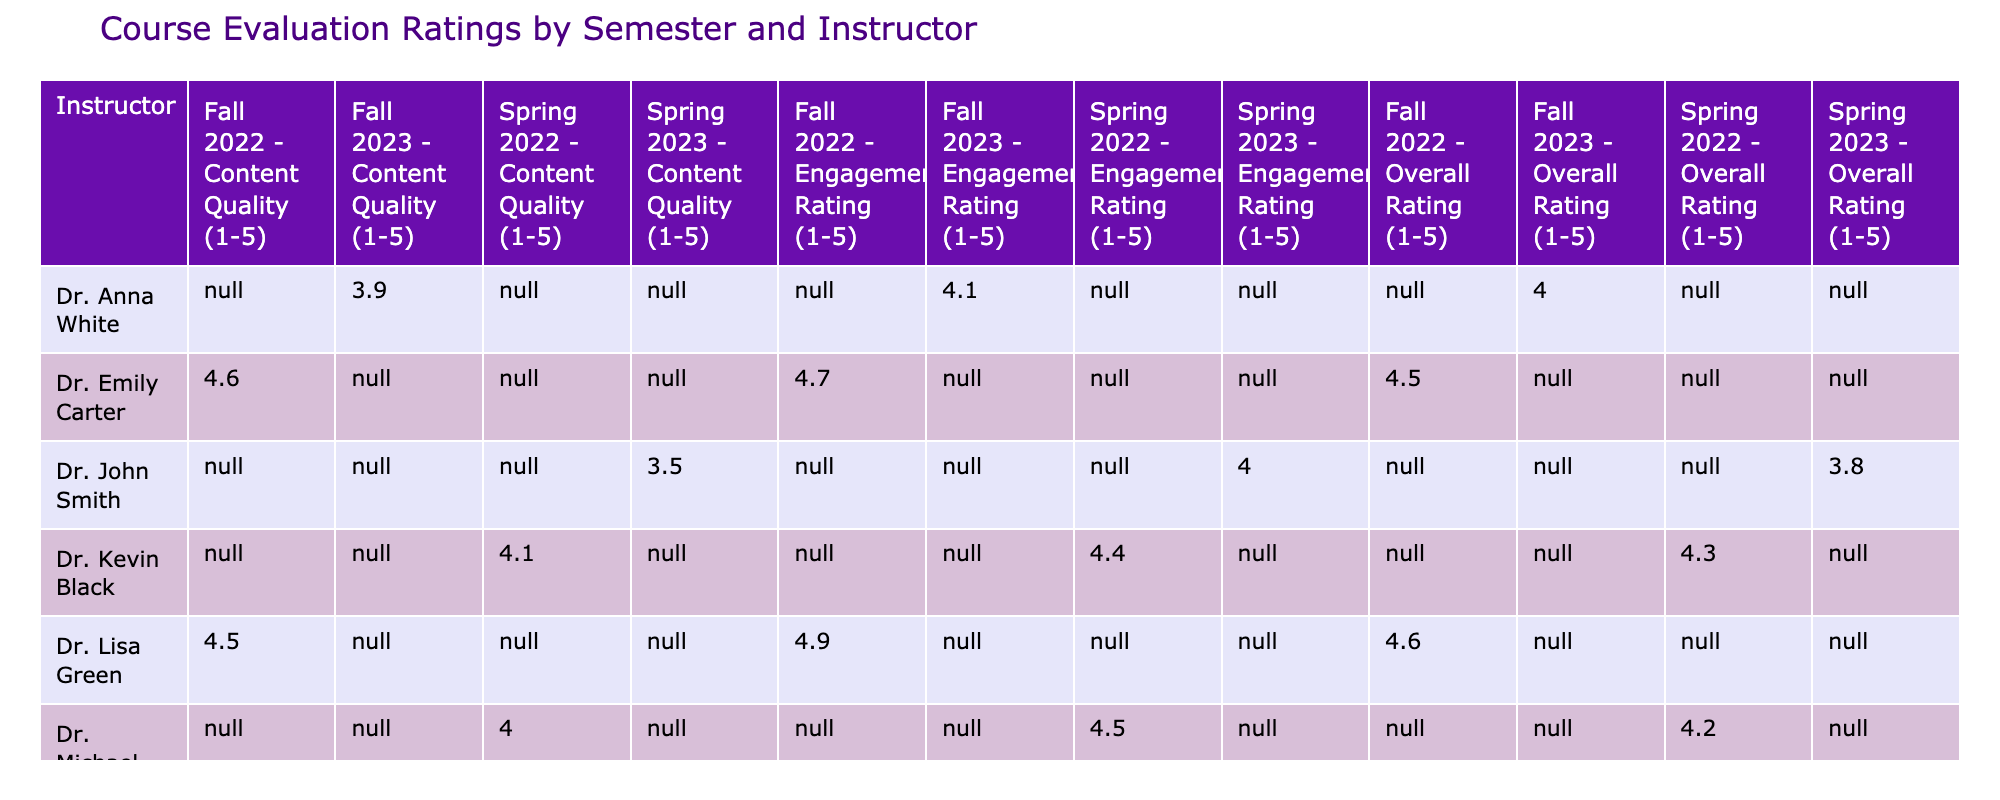What is the Overall Rating for Dr. Sarah Johnson's Shakespearean Studies class? The Overall Rating for Dr. Sarah Johnson's class in Fall 2023 can be found directly in the table under her name and the column for Fall 2023. It shows 4.9.
Answer: 4.9 Which instructor received the lowest Engagement Rating among Spring 2023 courses? To find the lowest Engagement Rating for Spring 2023, we need to look at all the Engagement Ratings in that column. Dr. Robert Brown has an Engagement Rating of 3.8, which is lower than Dr. John Smith's 4.0. Hence, Dr. Robert Brown is the instructor with the lowest Engagement Rating.
Answer: Dr. Robert Brown What is the sum of the Overall Ratings for all courses taught by Dr. Kevin Black? The table shows that Dr. Kevin Black taught one course in Spring 2022 with an Overall Rating of 4.3. Since there is only one value, the sum is simply 4.3.
Answer: 4.3 Is Dr. Lisa Green's Content Quality rating higher than Dr. Emily Carter's for their respective courses? Dr. Lisa Green's Content Quality rating is 4.5 for Women Writers and Dr. Emily Carter's is 4.6 for Literary Theory. Comparing these values indicates 4.5 is not higher than 4.6, thus the statement is false.
Answer: No What is the average Overall Rating across all courses in Fall 2023? The Overall Ratings for Fall 2023 courses are 4.9 (Dr. Sarah Johnson) and 4.0 (Dr. Anna White). To find the average, we sum these ratings: 4.9 + 4.0 = 8.9, then divide by 2 (the number of courses) resulting in 8.9 / 2 = 4.45.
Answer: 4.45 Which course had the highest Content Quality rating? By scanning through the Content Quality ratings in the table, Dr. Sarah Johnson's Shakespearean Studies class has the highest rating of 5.0, which is the maximum possible rating.
Answer: Shakespearean Studies Did any instructor receive identical Overall Ratings in different courses? Looking through the Overall Ratings shows no instructors have the same rating in any two of their courses. Each rating is distinct across their taught courses. Therefore, the answer to the question is no.
Answer: No What is the difference in Engagement Ratings between the highest and lowest rated instructors in the table? The highest Engagement Rating is 4.9 (Dr. Lisa Green) and the lowest is 3.5 (Dr. Robert Brown). To find the difference, we subtract the lowest from the highest: 4.9 - 3.5 = 1.4.
Answer: 1.4 